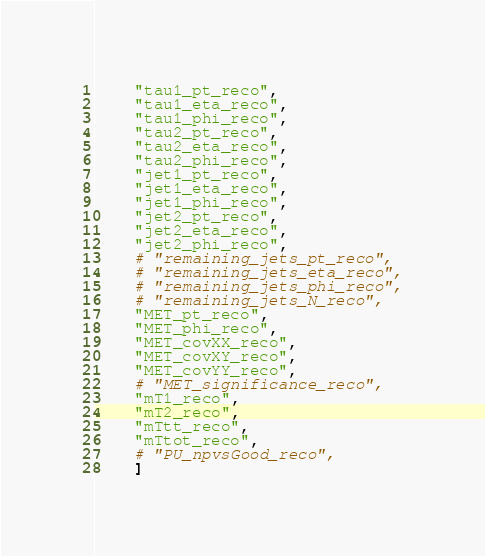<code> <loc_0><loc_0><loc_500><loc_500><_Python_>    "tau1_pt_reco",
    "tau1_eta_reco",
    "tau1_phi_reco",
    "tau2_pt_reco",
    "tau2_eta_reco",
    "tau2_phi_reco",
    "jet1_pt_reco",
    "jet1_eta_reco",
    "jet1_phi_reco",
    "jet2_pt_reco",
    "jet2_eta_reco",
    "jet2_phi_reco",
    # "remaining_jets_pt_reco",
    # "remaining_jets_eta_reco",
    # "remaining_jets_phi_reco",
    # "remaining_jets_N_reco",
    "MET_pt_reco",
    "MET_phi_reco",
    "MET_covXX_reco",
    "MET_covXY_reco",
    "MET_covYY_reco",
    # "MET_significance_reco",
    "mT1_reco",
    "mT2_reco",
    "mTtt_reco",
    "mTtot_reco",
    # "PU_npvsGood_reco",
    ]
</code> 